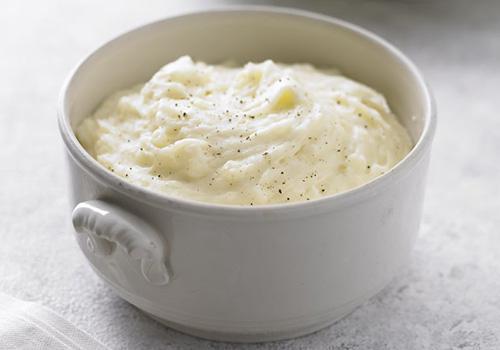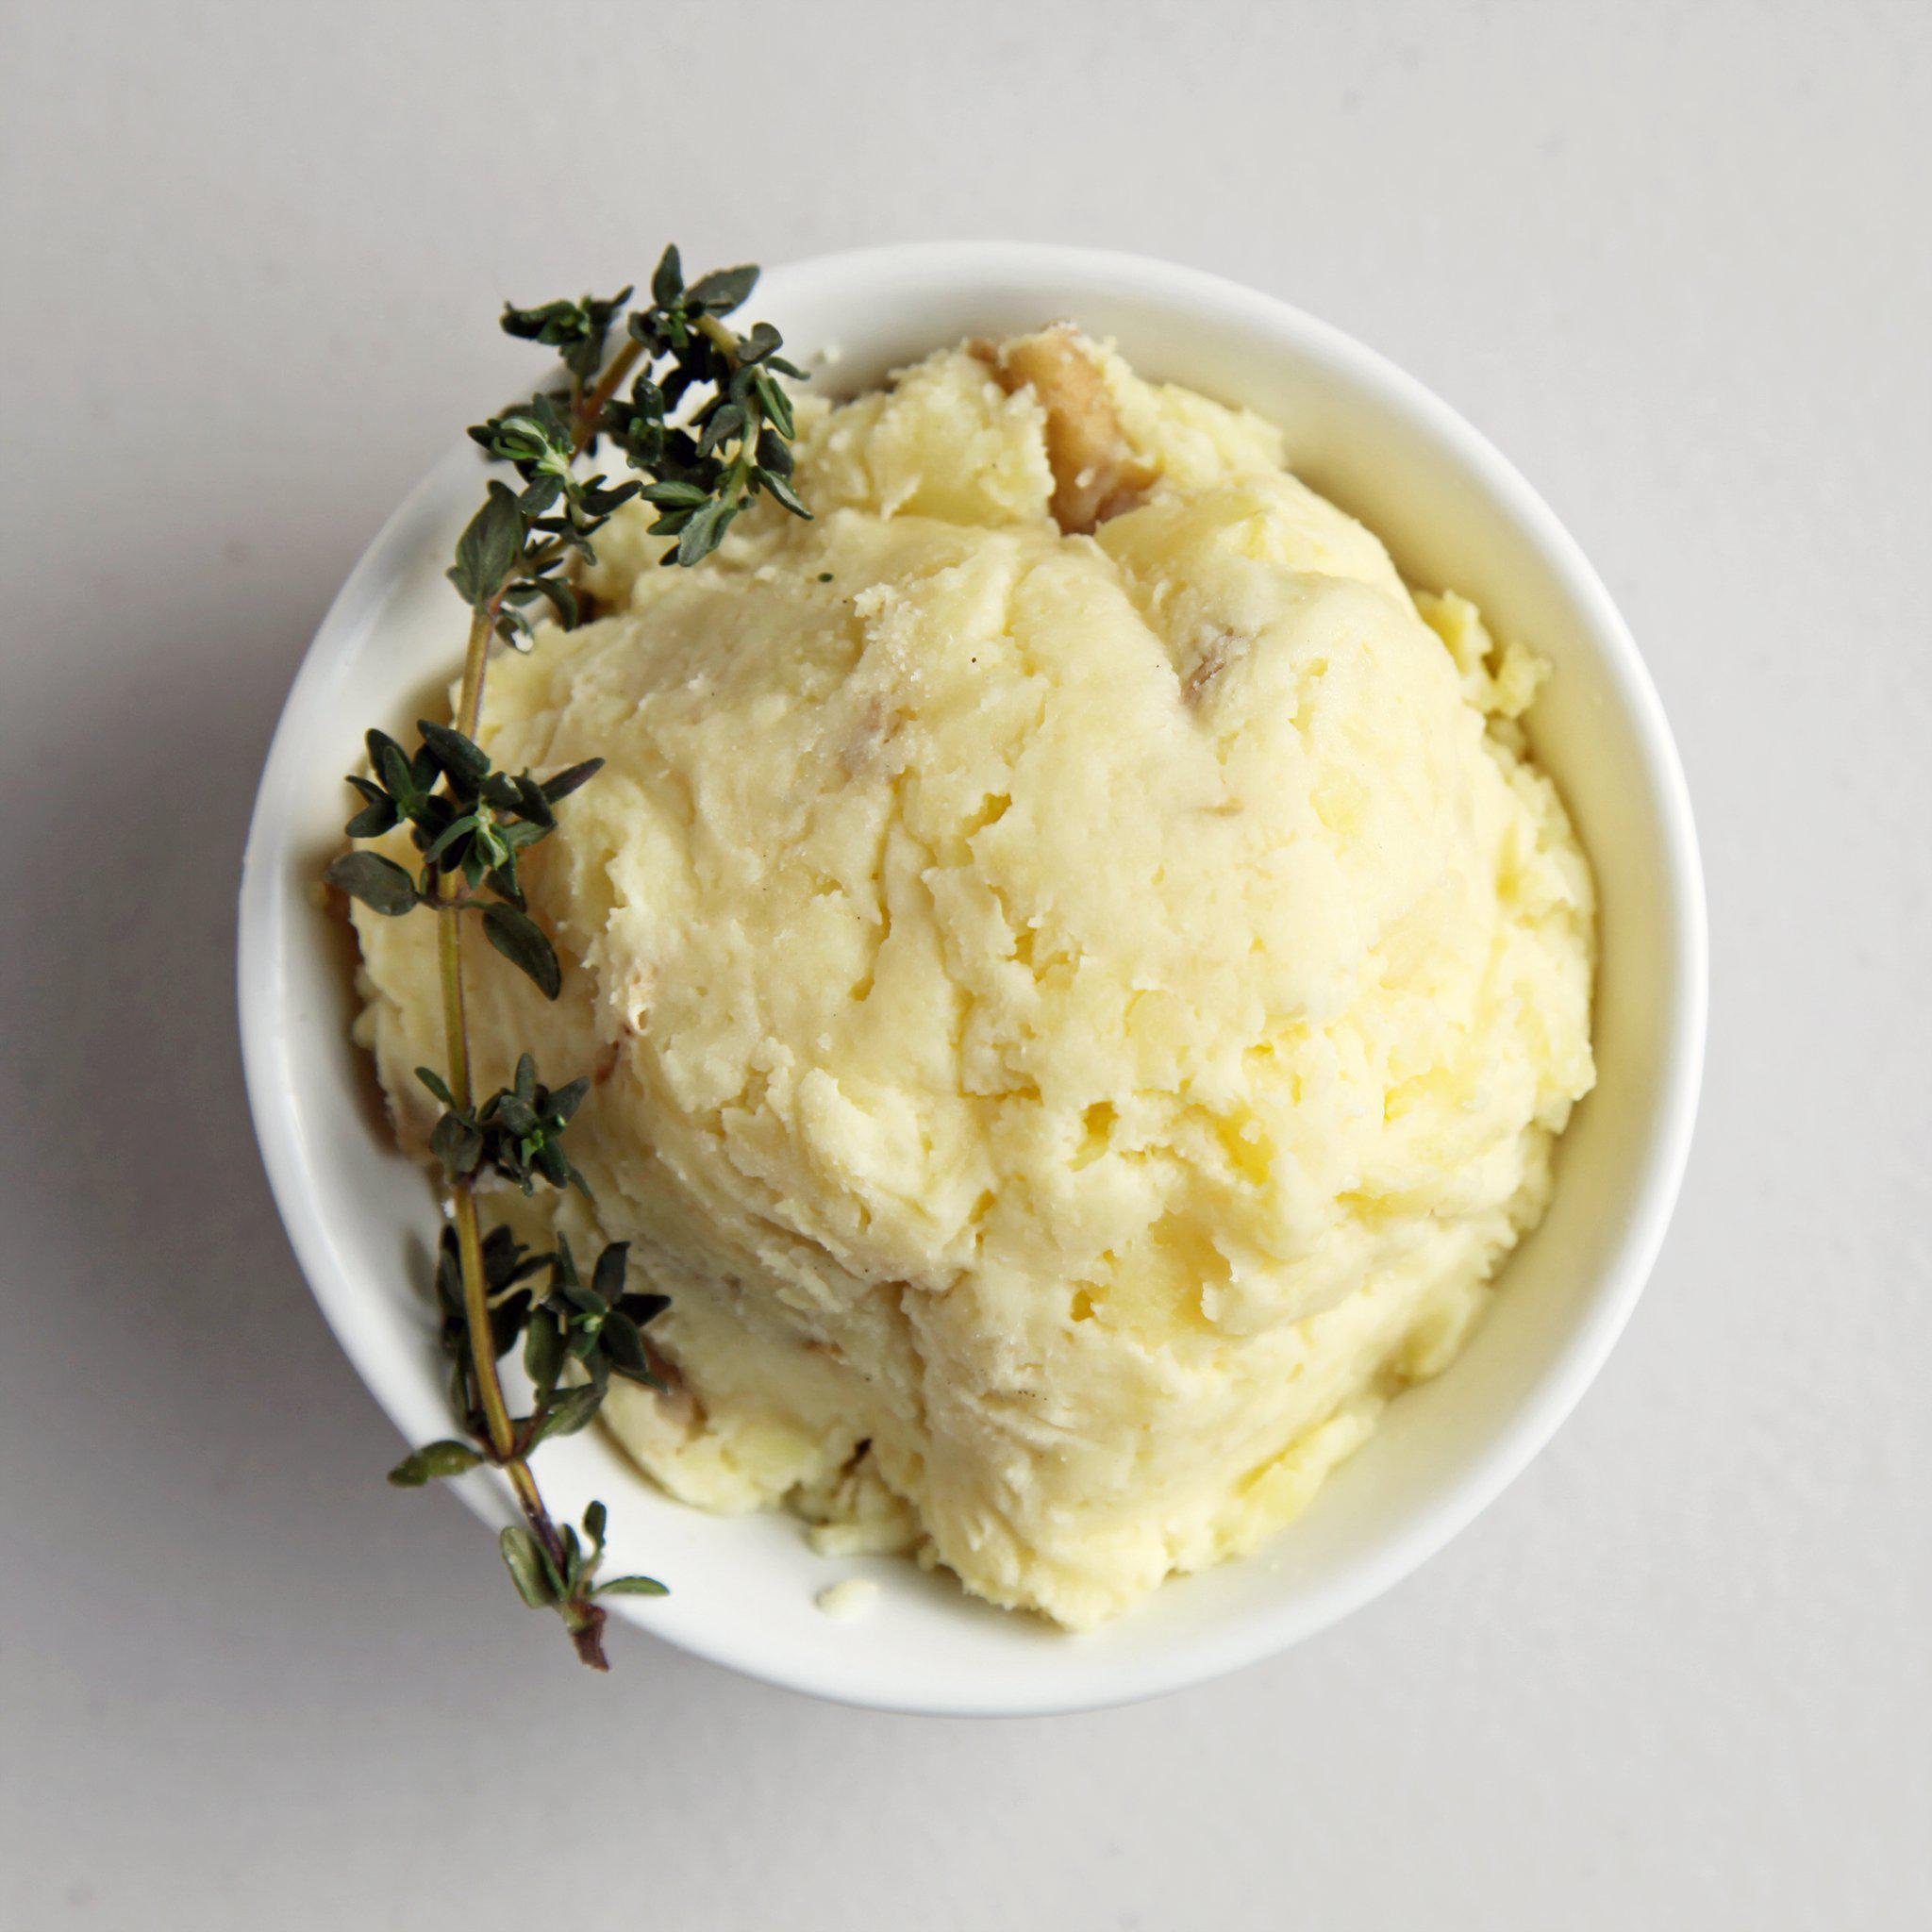The first image is the image on the left, the second image is the image on the right. Assess this claim about the two images: "A white bowl is holding the food in the image on the right.". Correct or not? Answer yes or no. Yes. The first image is the image on the left, the second image is the image on the right. For the images displayed, is the sentence "At least one image shows mashed potatoes in a round white bowl." factually correct? Answer yes or no. Yes. 